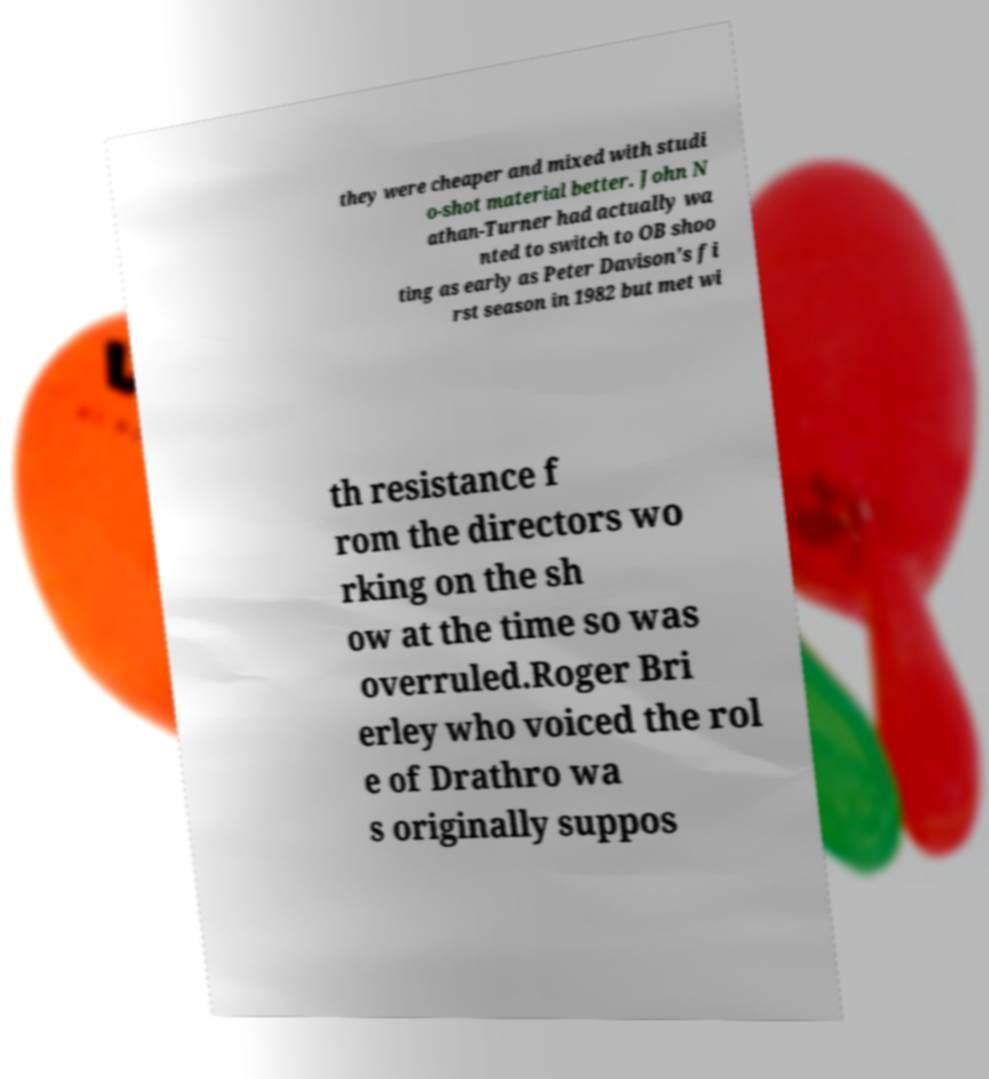Please identify and transcribe the text found in this image. they were cheaper and mixed with studi o-shot material better. John N athan-Turner had actually wa nted to switch to OB shoo ting as early as Peter Davison's fi rst season in 1982 but met wi th resistance f rom the directors wo rking on the sh ow at the time so was overruled.Roger Bri erley who voiced the rol e of Drathro wa s originally suppos 